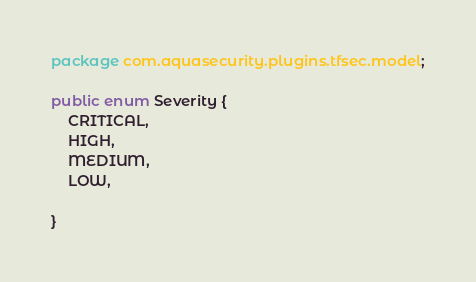Convert code to text. <code><loc_0><loc_0><loc_500><loc_500><_Java_>package com.aquasecurity.plugins.tfsec.model;

public enum Severity {
    CRITICAL,
    HIGH,
    MEDIUM,
    LOW,

}
</code> 